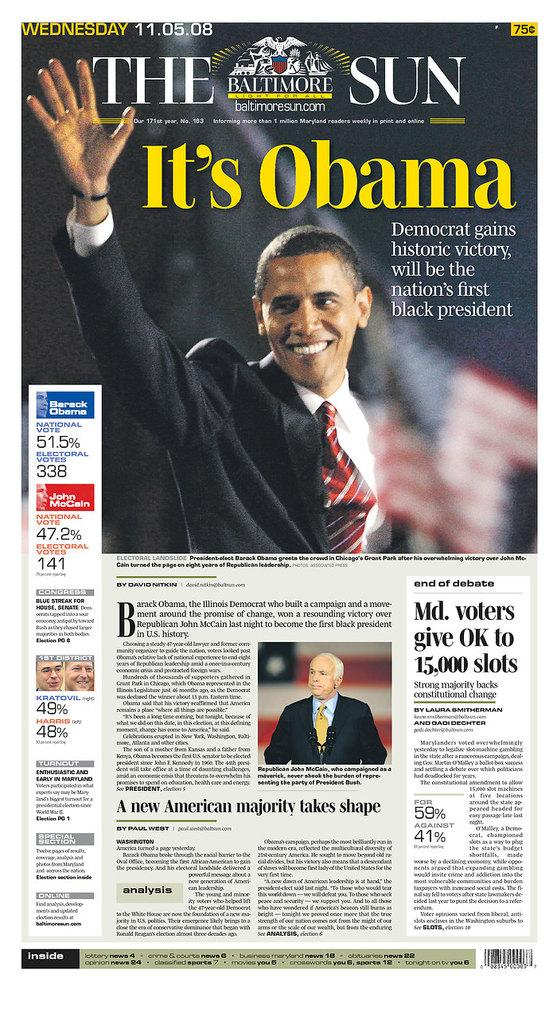What is present in the image that contains information or a message? There is a poster in the image that contains information or a message. What type of content is on the poster? The poster contains text and images of persons. How many cows are visible on the poster in the image? There are no cows visible on the poster in the image; it contains text and images of persons. 